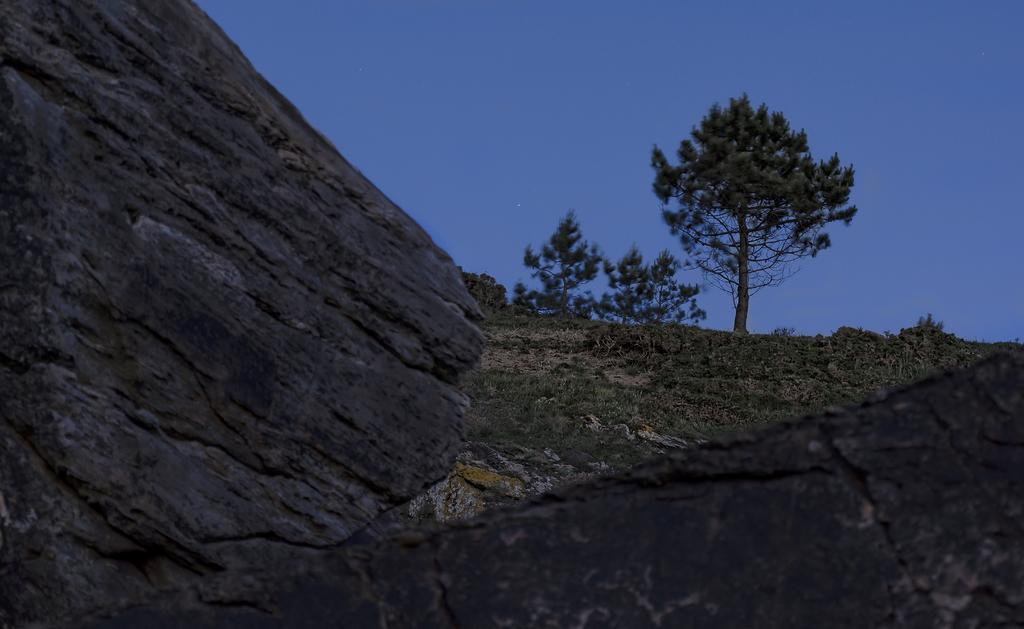What type of natural elements can be seen in the image? There are rocks, grass, and trees in the image. What is the color of the sky in the image? The sky is blue and visible at the top of the image. How many trucks can be seen driving on the rocks in the image? There are no trucks present in the image; it features rocks, grass, trees, and a blue sky. 